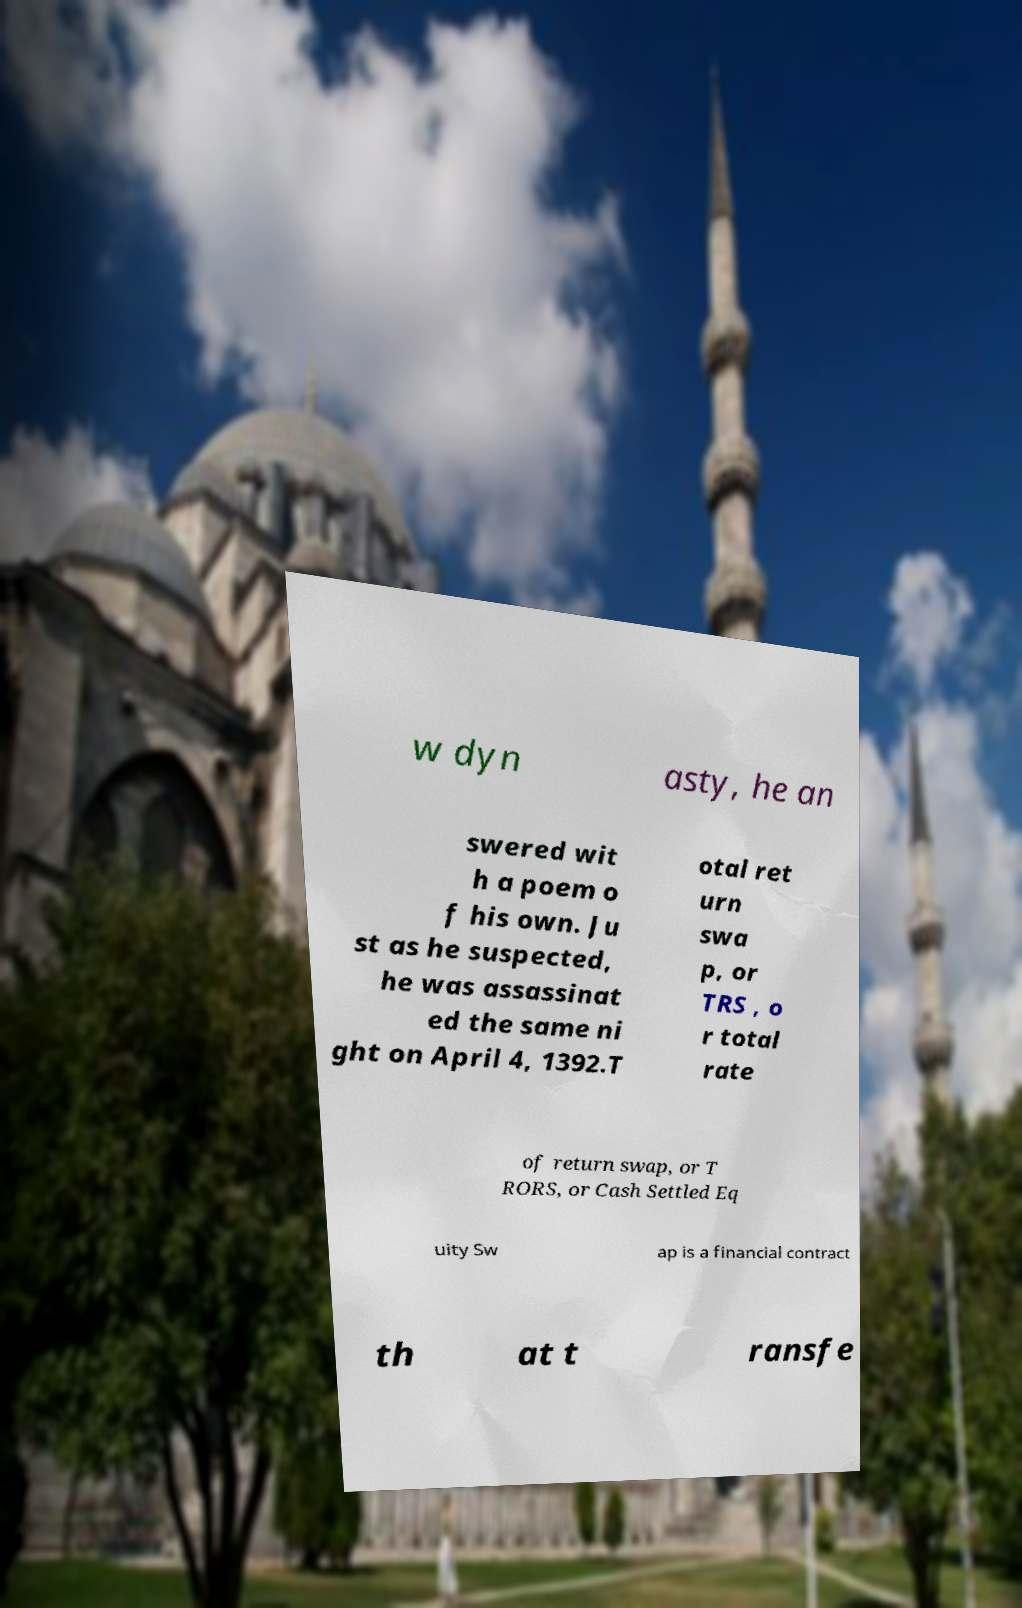I need the written content from this picture converted into text. Can you do that? w dyn asty, he an swered wit h a poem o f his own. Ju st as he suspected, he was assassinat ed the same ni ght on April 4, 1392.T otal ret urn swa p, or TRS , o r total rate of return swap, or T RORS, or Cash Settled Eq uity Sw ap is a financial contract th at t ransfe 